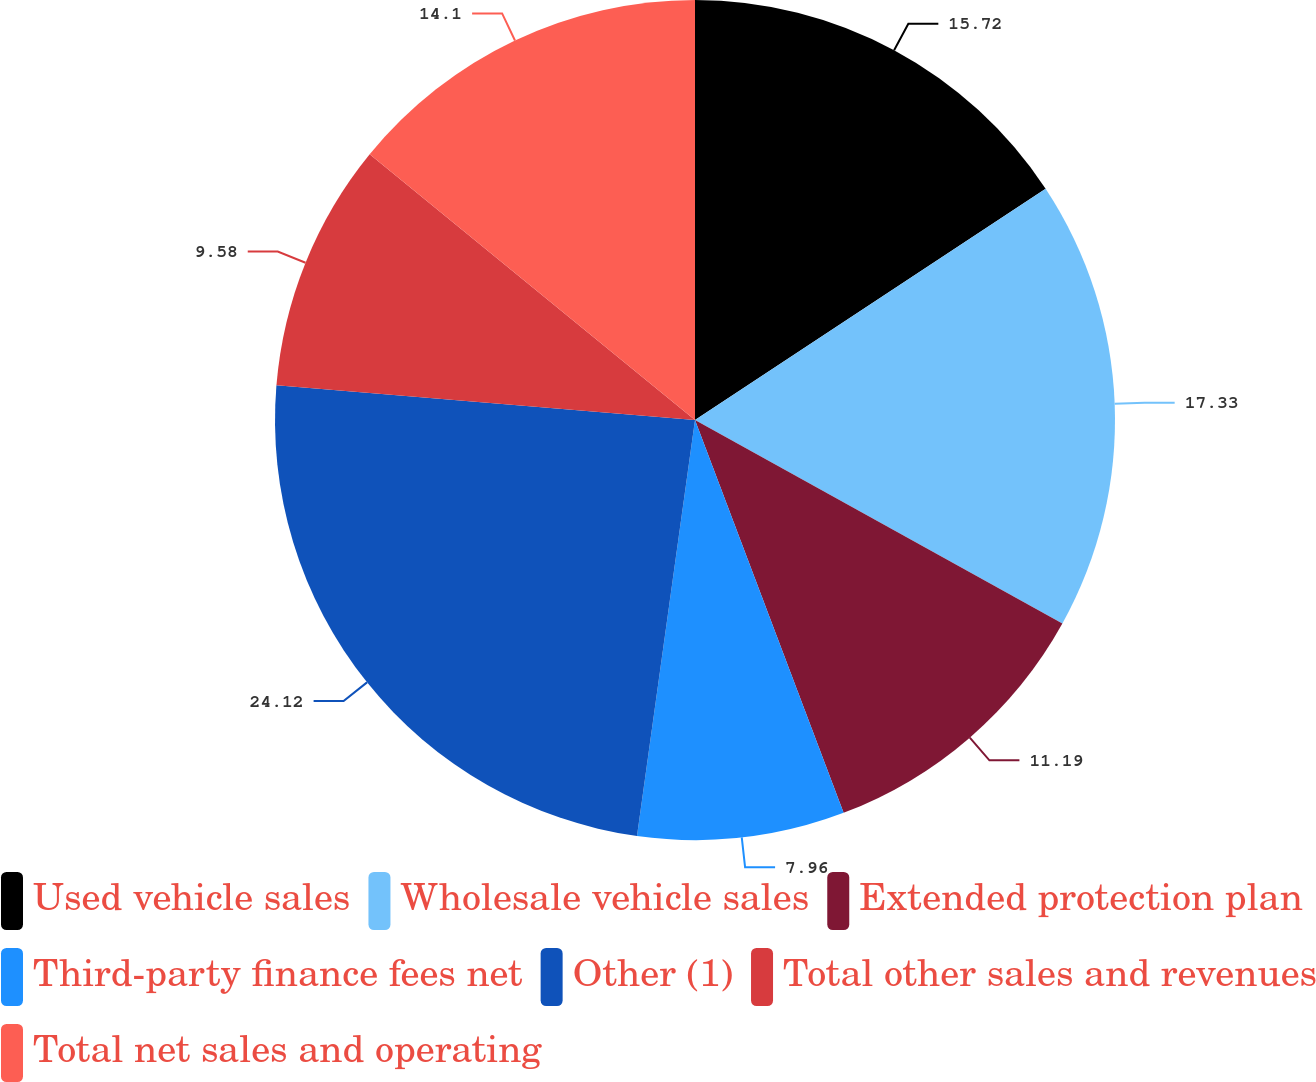Convert chart. <chart><loc_0><loc_0><loc_500><loc_500><pie_chart><fcel>Used vehicle sales<fcel>Wholesale vehicle sales<fcel>Extended protection plan<fcel>Third-party finance fees net<fcel>Other (1)<fcel>Total other sales and revenues<fcel>Total net sales and operating<nl><fcel>15.72%<fcel>17.33%<fcel>11.19%<fcel>7.96%<fcel>24.11%<fcel>9.58%<fcel>14.1%<nl></chart> 